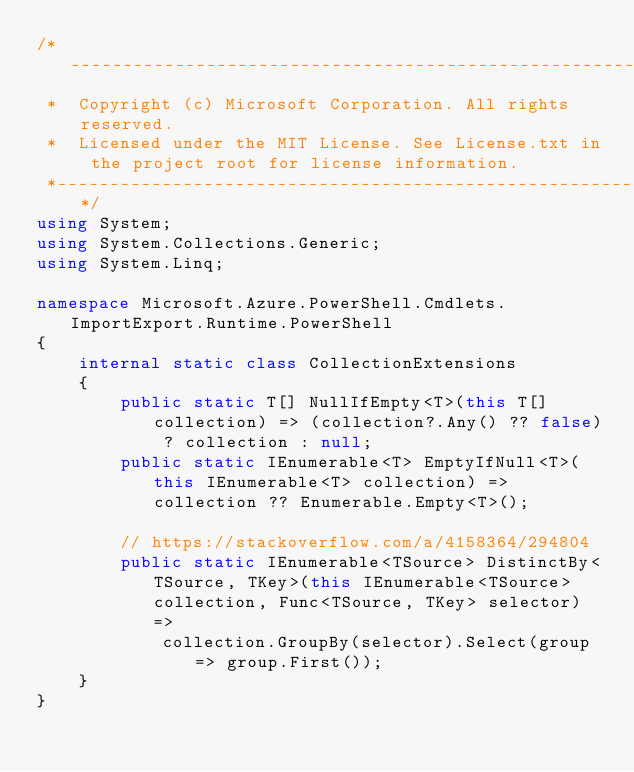Convert code to text. <code><loc_0><loc_0><loc_500><loc_500><_C#_>/*---------------------------------------------------------------------------------------------
 *  Copyright (c) Microsoft Corporation. All rights reserved.
 *  Licensed under the MIT License. See License.txt in the project root for license information.
 *--------------------------------------------------------------------------------------------*/
using System;
using System.Collections.Generic;
using System.Linq;

namespace Microsoft.Azure.PowerShell.Cmdlets.ImportExport.Runtime.PowerShell
{
    internal static class CollectionExtensions
    {
        public static T[] NullIfEmpty<T>(this T[] collection) => (collection?.Any() ?? false) ? collection : null;
        public static IEnumerable<T> EmptyIfNull<T>(this IEnumerable<T> collection) => collection ?? Enumerable.Empty<T>();

        // https://stackoverflow.com/a/4158364/294804
        public static IEnumerable<TSource> DistinctBy<TSource, TKey>(this IEnumerable<TSource> collection, Func<TSource, TKey> selector) =>
            collection.GroupBy(selector).Select(group => group.First());
    }
}
</code> 